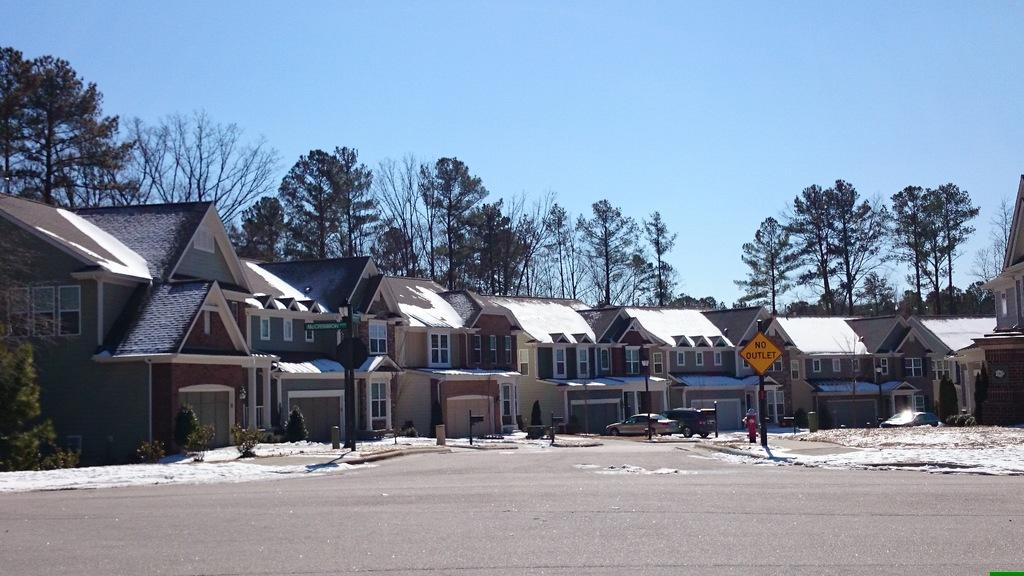What type of structures can be seen in the image? There are buildings in the image. What else can be seen moving around in the image? There are vehicles in the image. What type of natural elements are present in the image? There are plants and trees in the image. What is a specific object related to fire safety in the image? There is a fire hydrant in the image. What type of vertical structures can be seen in the image? There are poles in the image. What other objects are present on the ground in the image? There are other objects on the ground in the image. What can be seen in the background of the image, beyond the buildings and trees? The sky is visible in the background of the image. What type of prose can be seen written on the buildings in the image? There is no prose visible on the buildings in the image. What type of cord is used to connect the vehicles in the image? There is no mention of cords connecting vehicles in the image. 